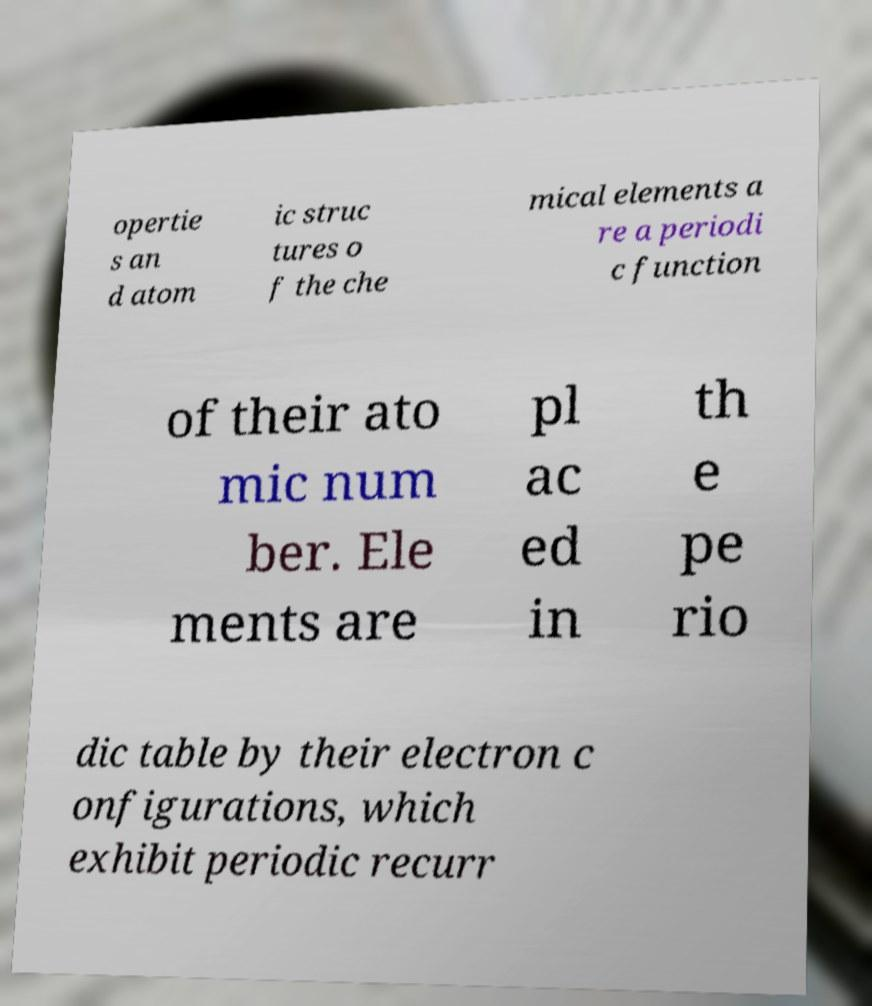I need the written content from this picture converted into text. Can you do that? opertie s an d atom ic struc tures o f the che mical elements a re a periodi c function of their ato mic num ber. Ele ments are pl ac ed in th e pe rio dic table by their electron c onfigurations, which exhibit periodic recurr 